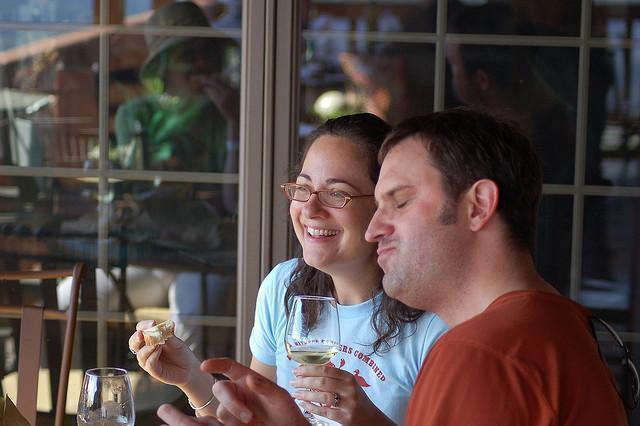How many females are in the photo?
Give a very brief answer. 1. How many reading glasses do you see?
Give a very brief answer. 1. How many people are there?
Give a very brief answer. 4. How many wine glasses are there?
Give a very brief answer. 2. 